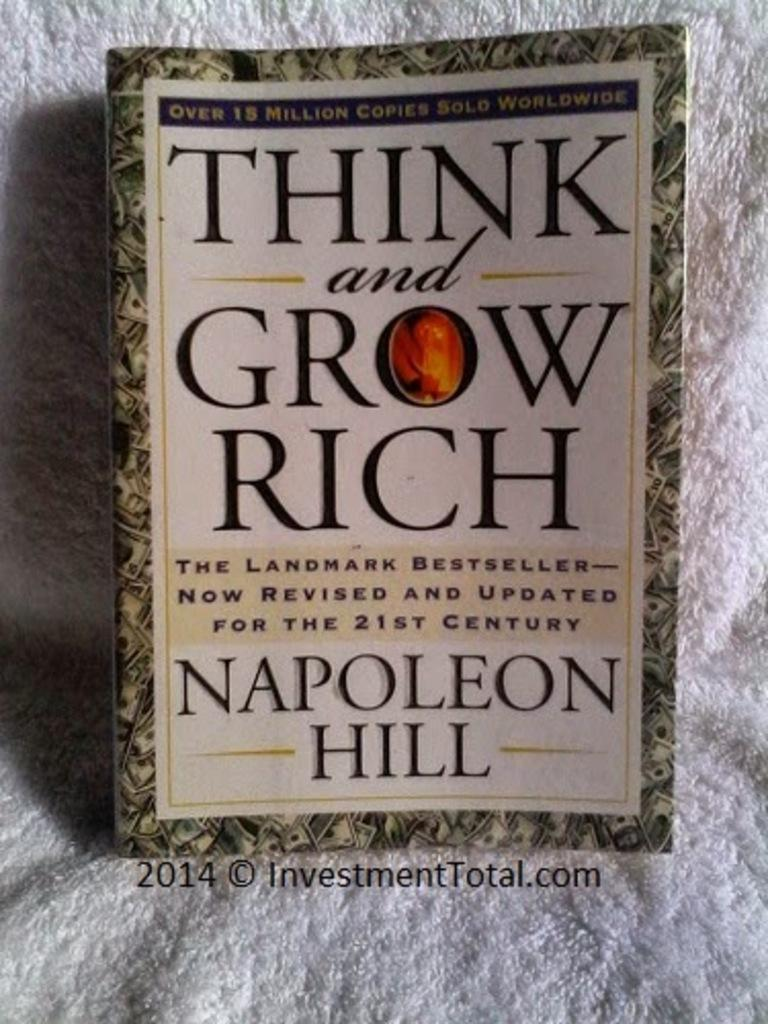<image>
Relay a brief, clear account of the picture shown. A book titles, "Think and Grow Rich" sits on a white towel. 